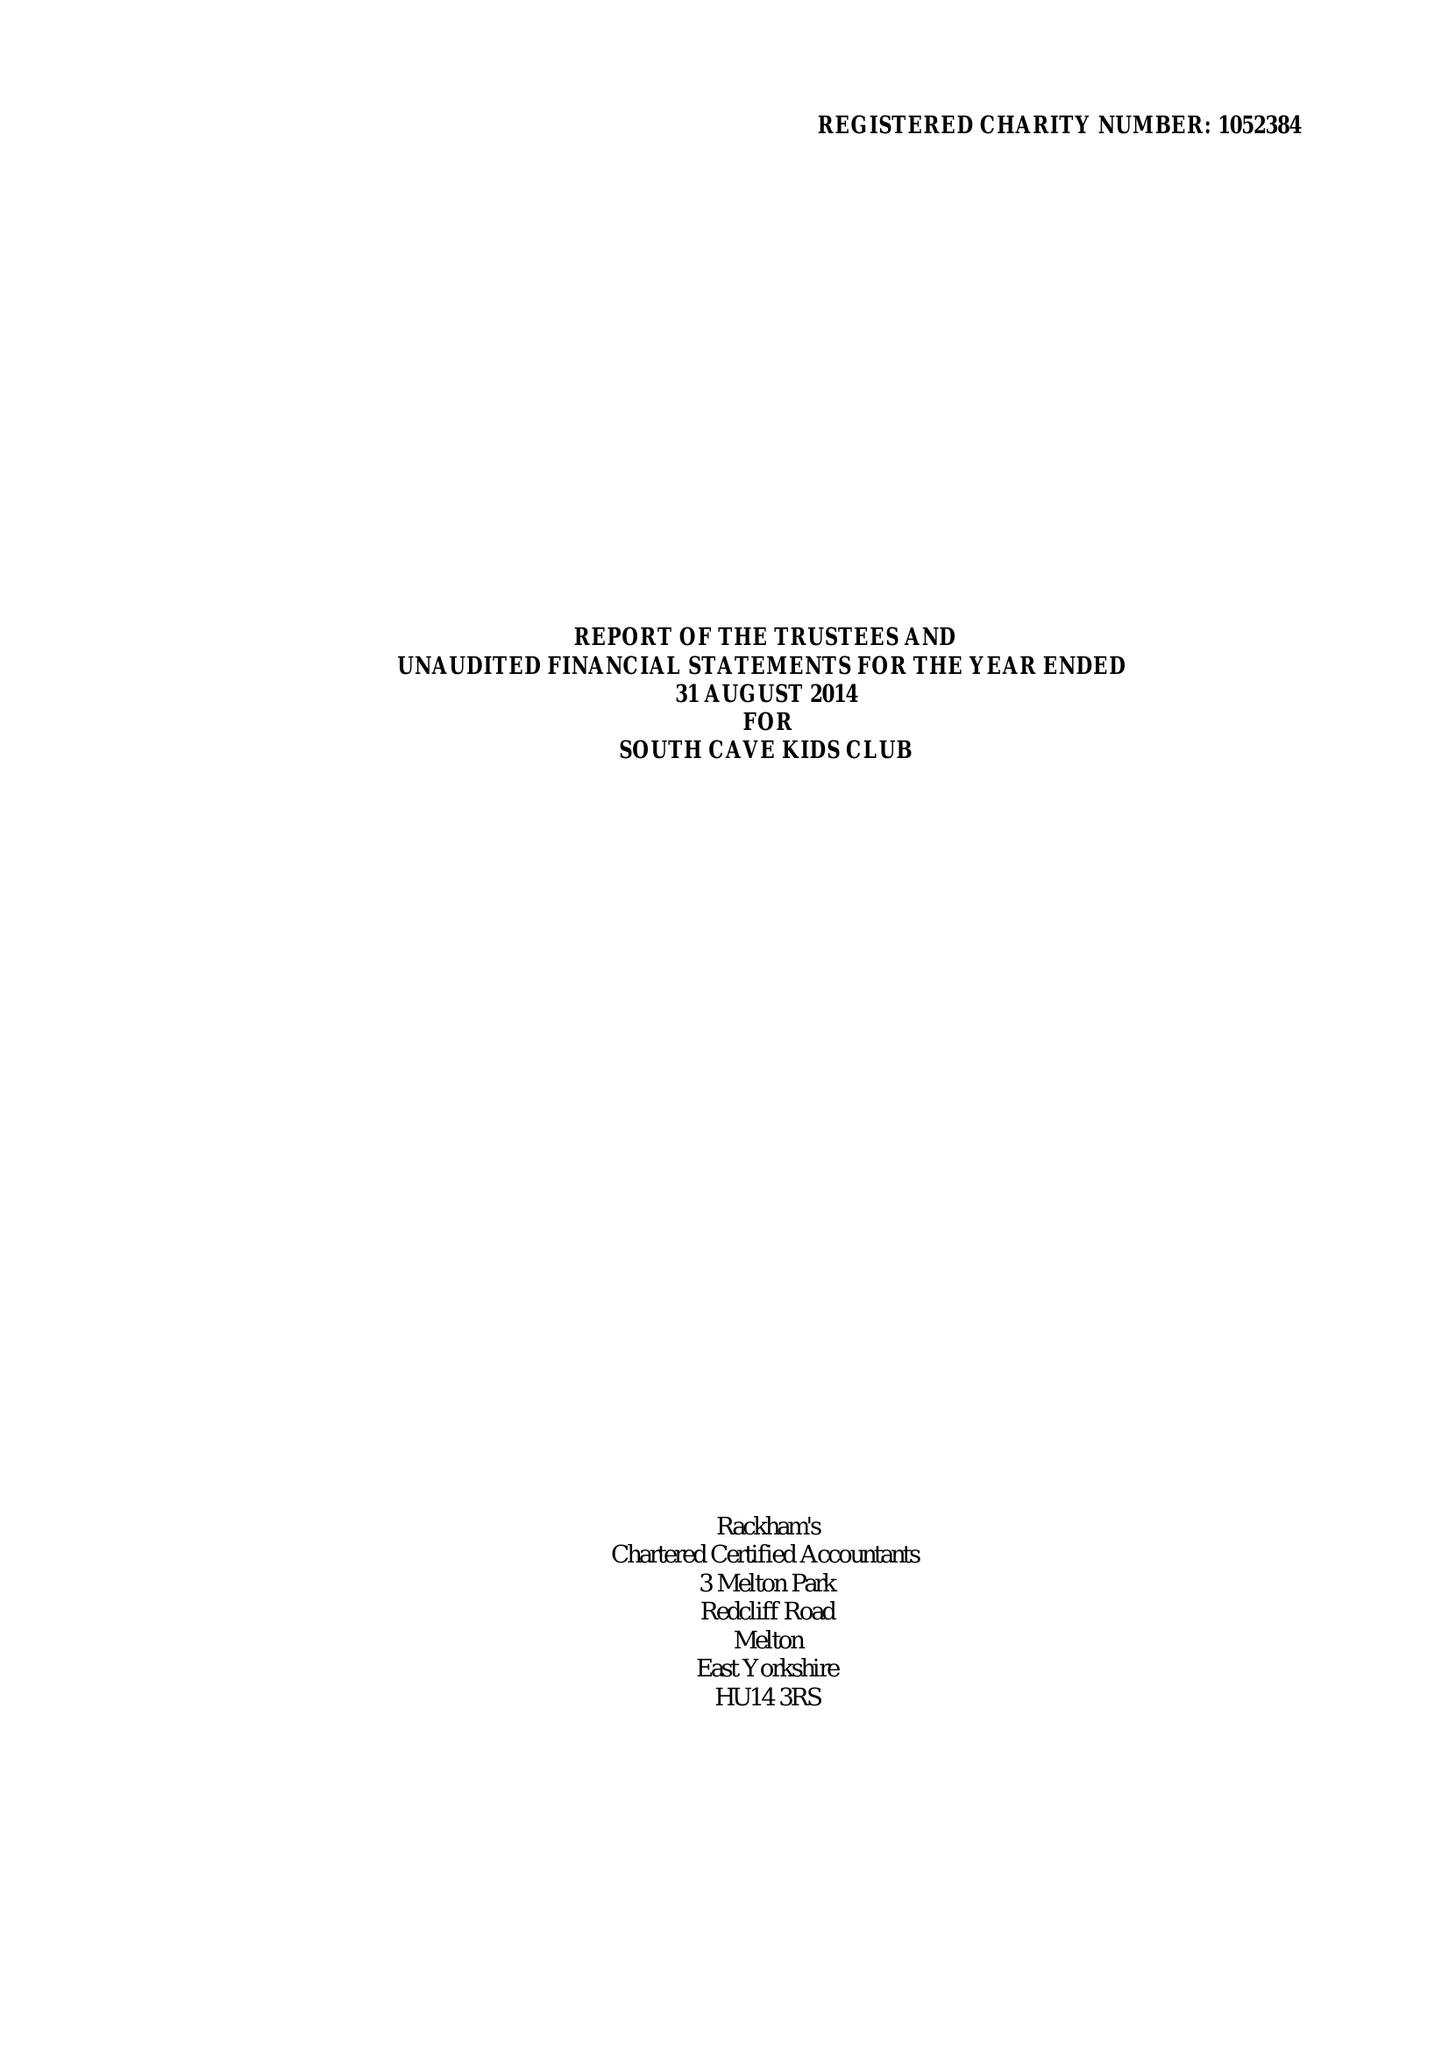What is the value for the income_annually_in_british_pounds?
Answer the question using a single word or phrase. 97546.00 